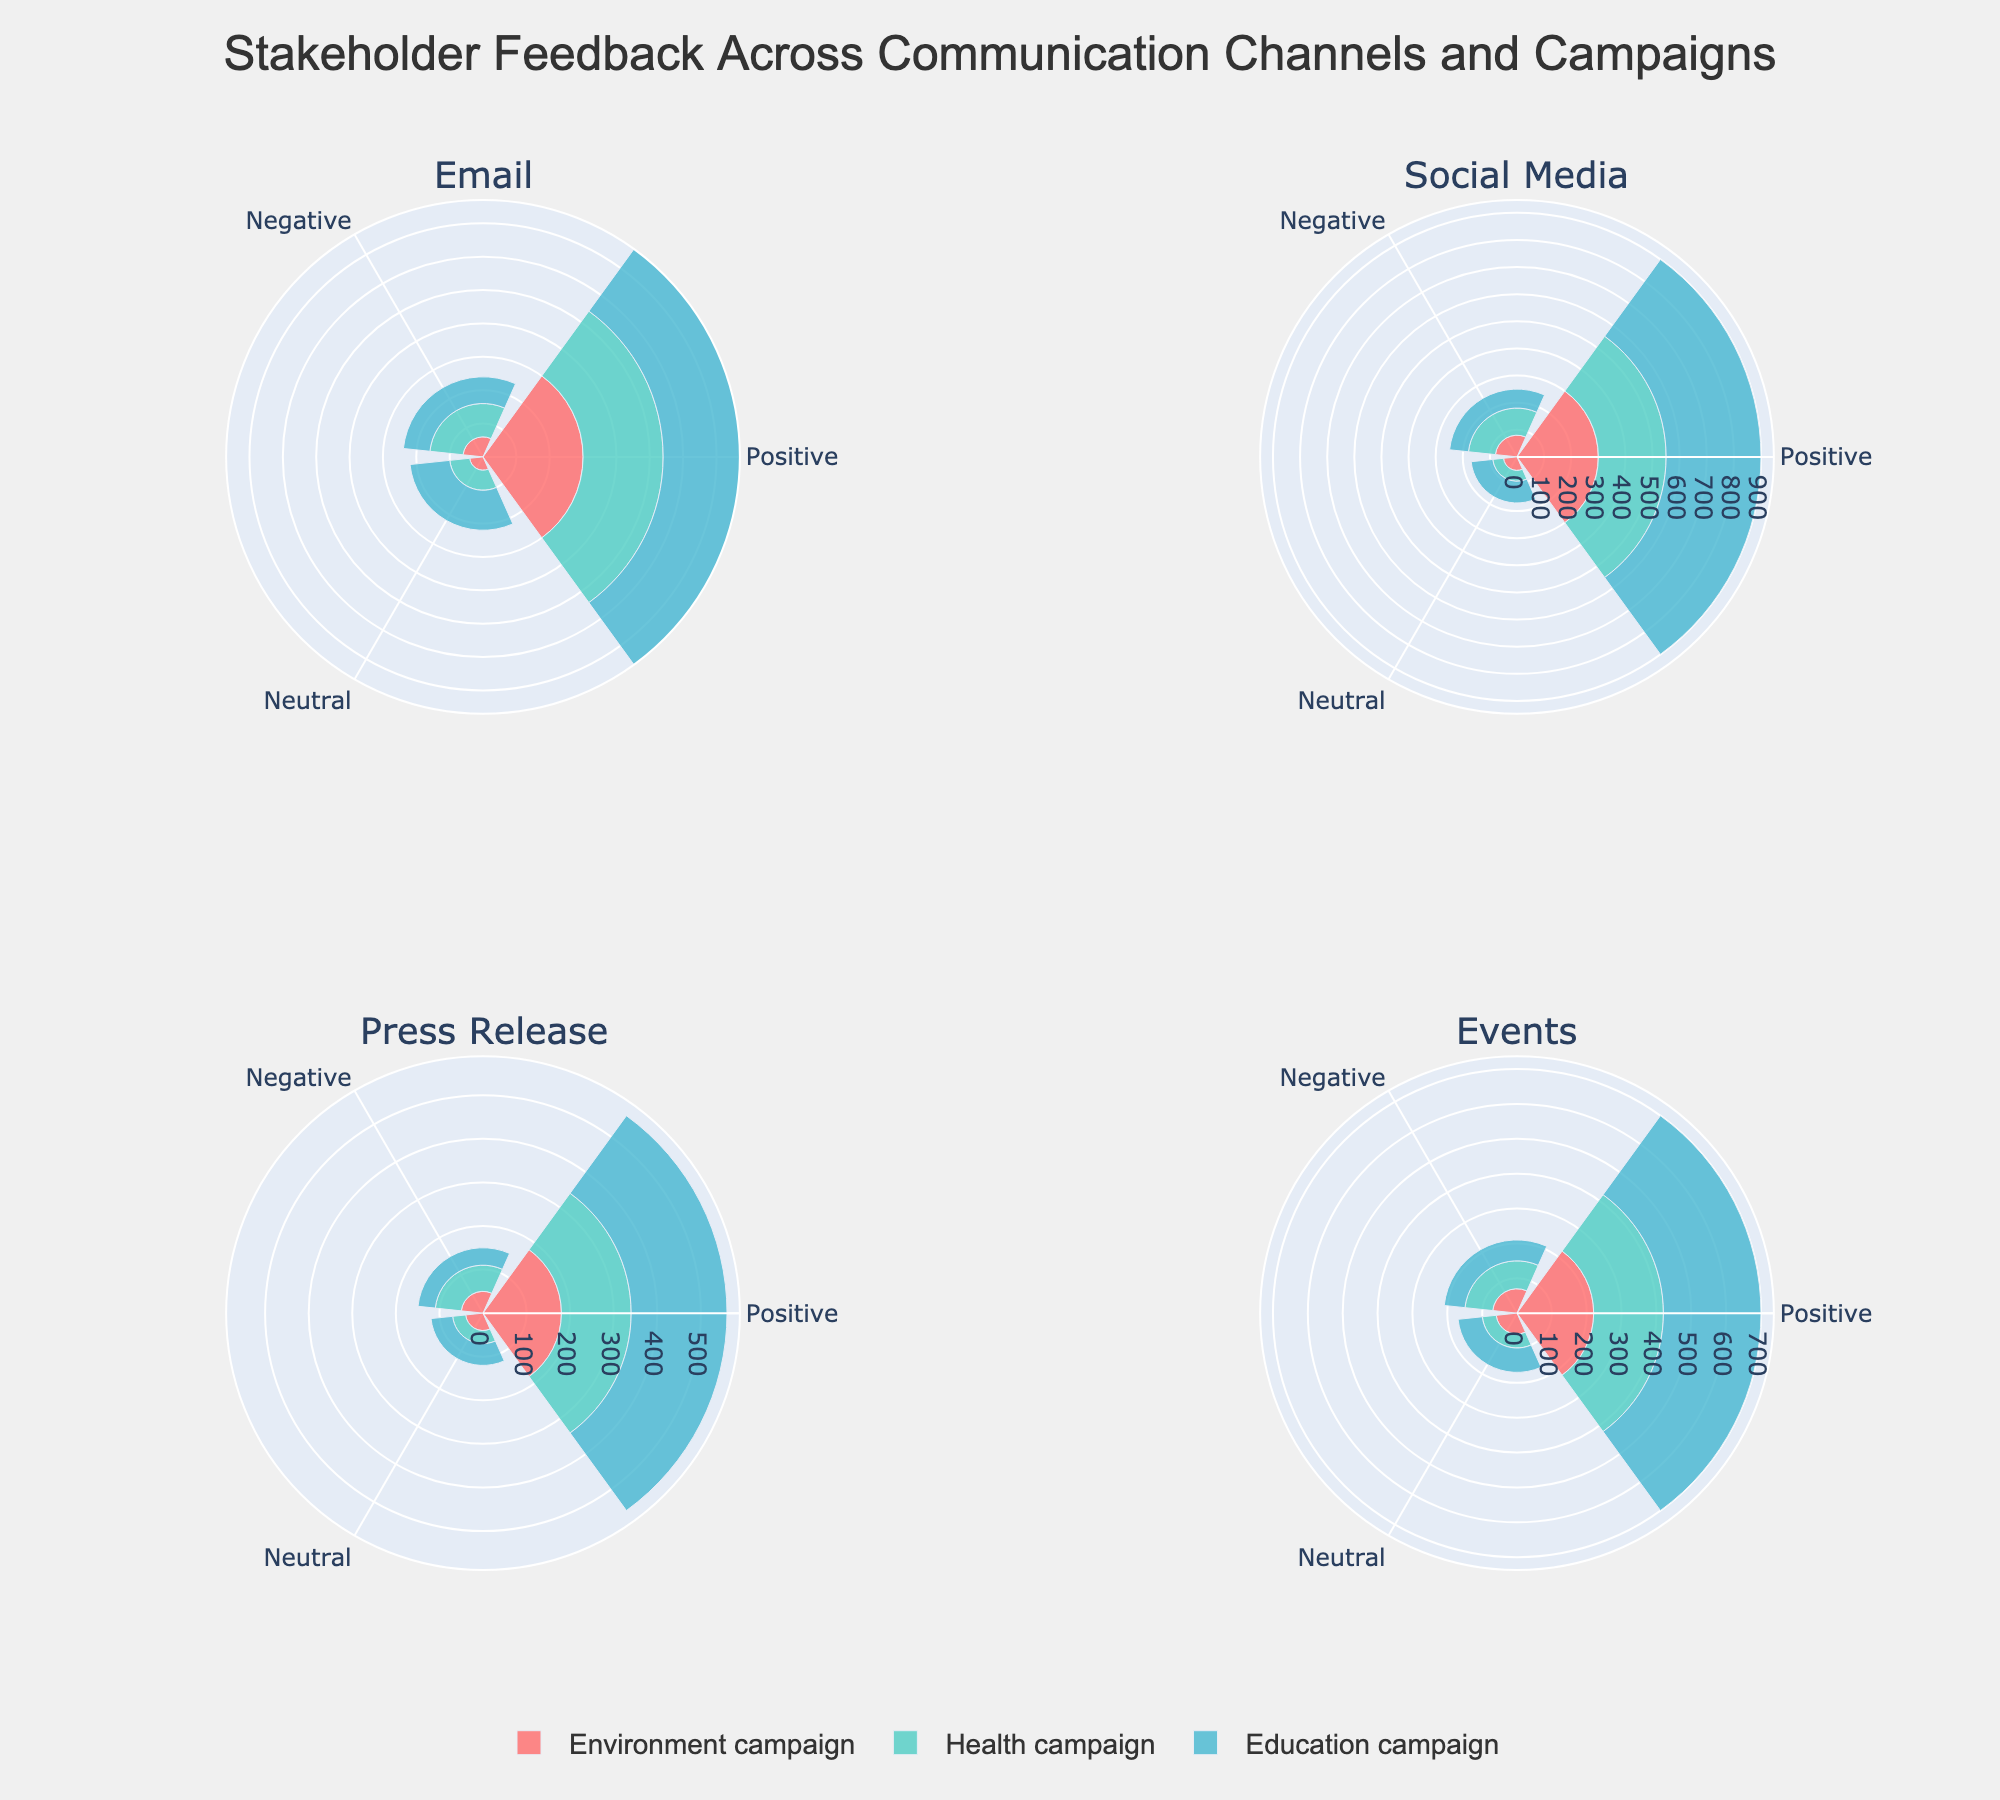What's the title of the figure? The title is usually displayed at the top of the figure and summarizes what the figure is about. Here, it's positioned in the center and mentions stakeholder feedback across different communication channels and campaigns.
Answer: Stakeholder Feedback Across Communication Channels and Campaigns How many communication channels are analyzed in the figure? The subplot titles at the corners of the figure represent the different communication channels. Counting them will give the number of channels analyzed.
Answer: Four Which campaign received the most positive feedback on Social Media? In the subplot for Social Media, the bar length corresponding to 'Positive Feedback' for each campaign must be checked. The longest bar represents the highest positive feedback.
Answer: Education campaign Compare the negative feedback for the Health campaign between Social Media and Events. You need to look at the lengths of the bars corresponding to 'Negative Feedback' for the Health campaign in both the Social Media and Events subplots. Compare these lengths directly.
Answer: Social Media has more negative feedback Which communication channel received the highest negative feedback for the Environment campaign? For each channel subplot, look for the Environment campaign and compare the lengths of the 'Negative Feedback' bars across the channels. The longest bar indicates the highest feedback.
Answer: Social Media Which communication channel has the least neutral feedback for the Health campaign? Look at the 'Neutral Feedback' bars for the Health campaign in each channel's subplot. Identify the shortest bar to find the least neutral feedback.
Answer: Press Release 